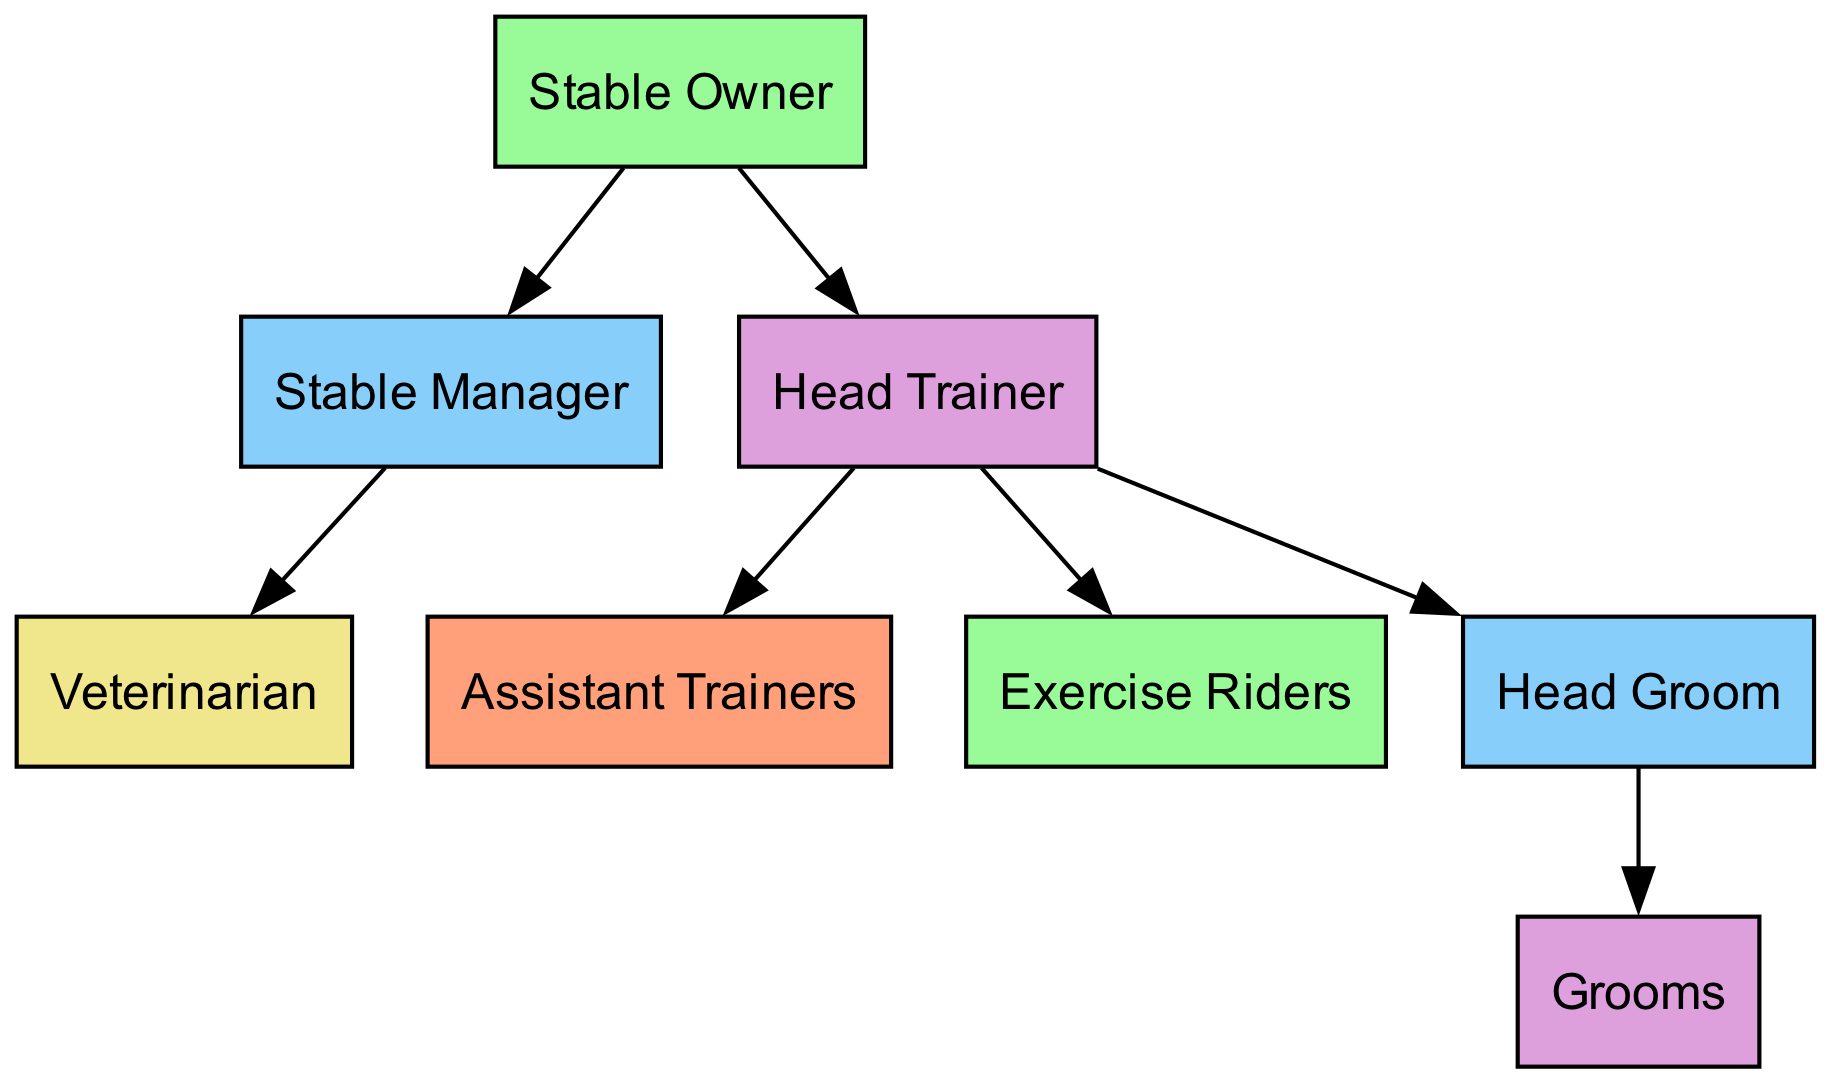What is the highest position in the stable hierarchy? The diagram indicates the highest position is labeled as "Stable Owner." This can be found at level 1 of the organizational structure and has no superior role above it.
Answer: Stable Owner How many nodes are present in the diagram? Counting all the unique roles listed in the diagram, we find eight nodes: Stable Owner, Stable Manager, Head Trainer, Veterinarian, Assistant Trainers, Exercise Riders, Head Groom, and Grooms. Therefore, the total number of nodes is eight.
Answer: 8 Who reports directly to the Stable Manager? The edge connecting "Stable Manager" to "Veterinarian" indicates that the Veterinarian reports directly to the Stable Manager, and is the only direct report represented in the diagram.
Answer: Veterinarian What level does the Head Groom occupy? The Head Groom is assigned to level 4 in the organizational structure according to the provided node data, indicating its position within the hierarchy.
Answer: 4 How many roles report directly to the Head Trainer? By examining the connections from the "Head Trainer," we can see there are three roles: "Assistant Trainers," "Exercise Riders," and "Head Groom." Thus, the total number of direct reports to the Head Trainer is three.
Answer: 3 What is the position directly below the Stable Owner? The roles listed directly below the Stable Owner in the diagram include both the "Stable Manager" and the "Head Trainer." This makes it clear that both are on level 2, answering the question of positions below the highest authority in the stable structure.
Answer: Stable Manager, Head Trainer Which role is at the bottom of the hierarchy? The "Grooms" hold the lowest position within the hierarchy, as illustrated by their placement at level 5, which is the last level in the diagram.
Answer: Grooms How many edges are in the diagram? Counting the connections between nodes, there are seven directed edges present, which represent relationships between different roles. This includes connections from the Stable Owner, Stable Manager, and Head Trainer to their respective reports.
Answer: 7 Which group does the Head Groom oversee? The Head Groom supervises the "Grooms," as shown by the edge from "Head Groom" to "Grooms," indicating a direct relationship between the two roles within the organizational structure.
Answer: Grooms 